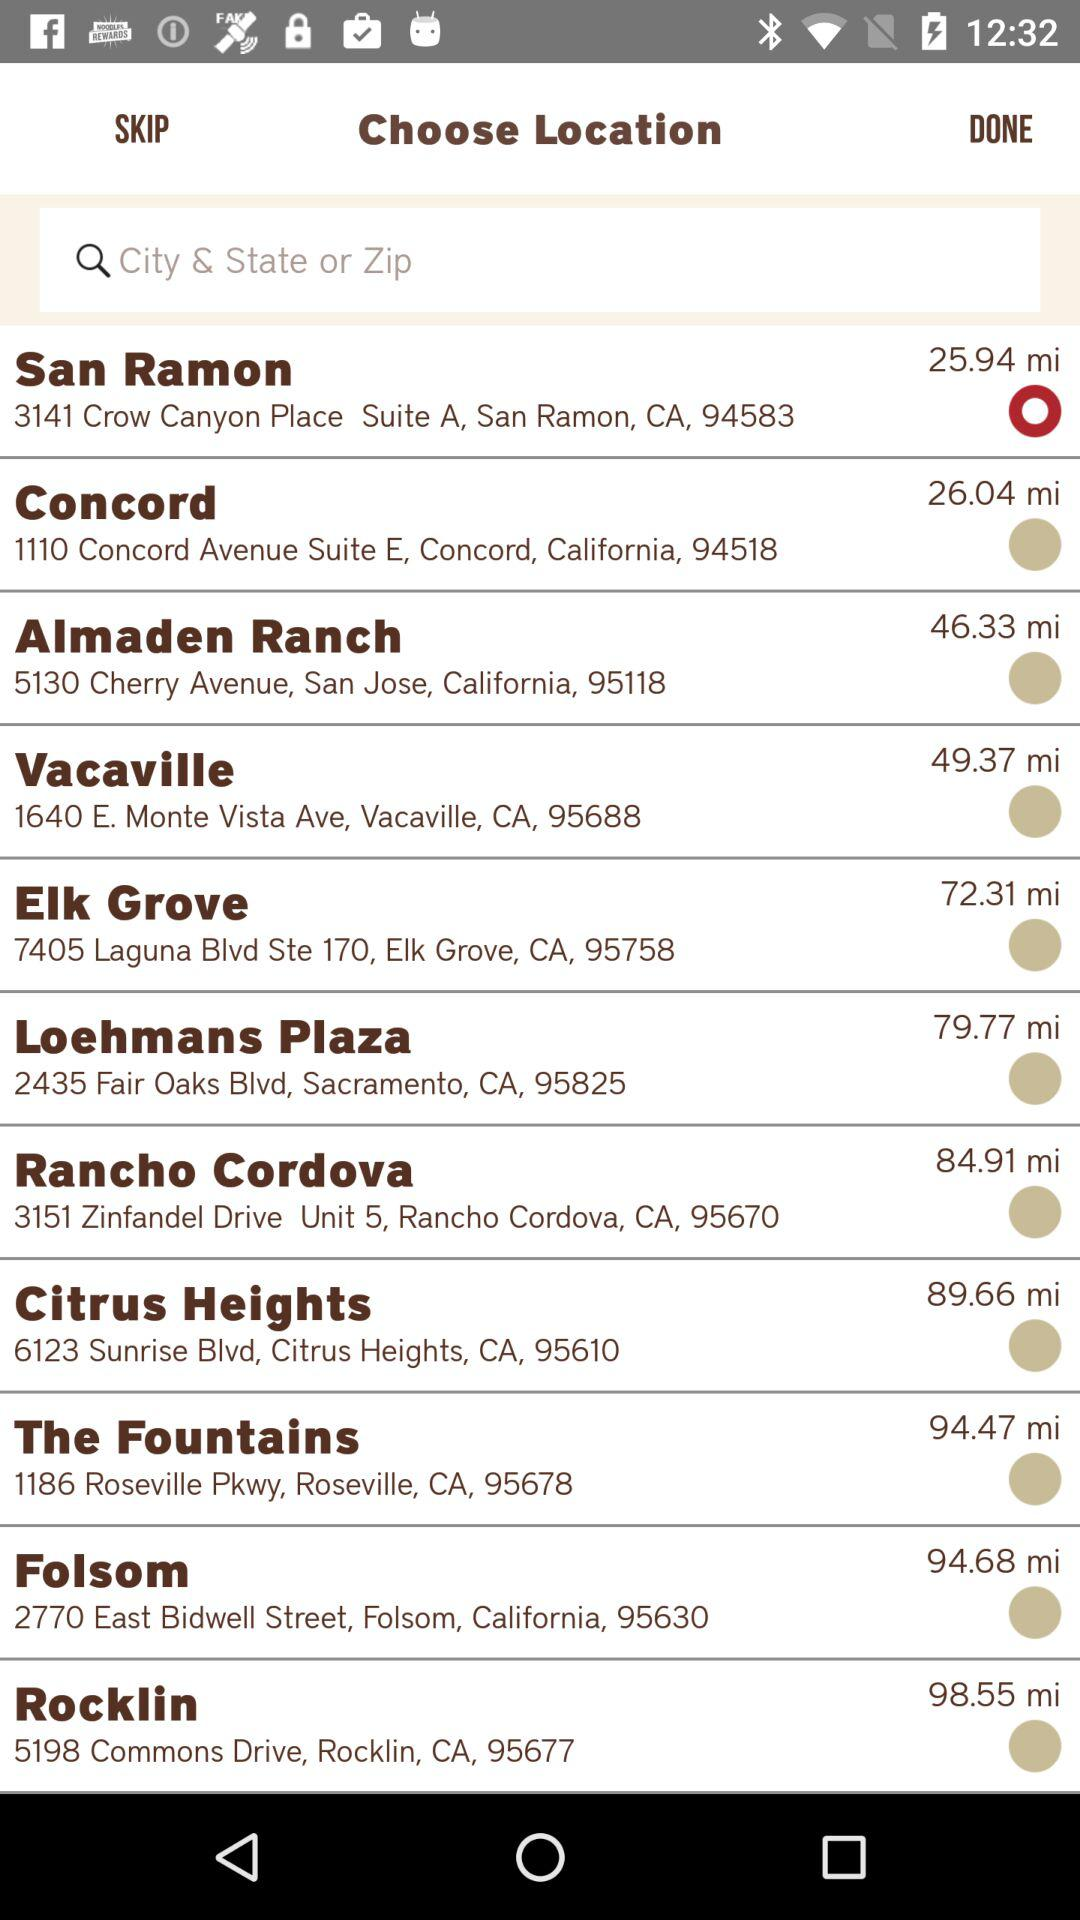How far is Rancho Cordova from my location? Rancho Cordova is 84.91 miles away. 